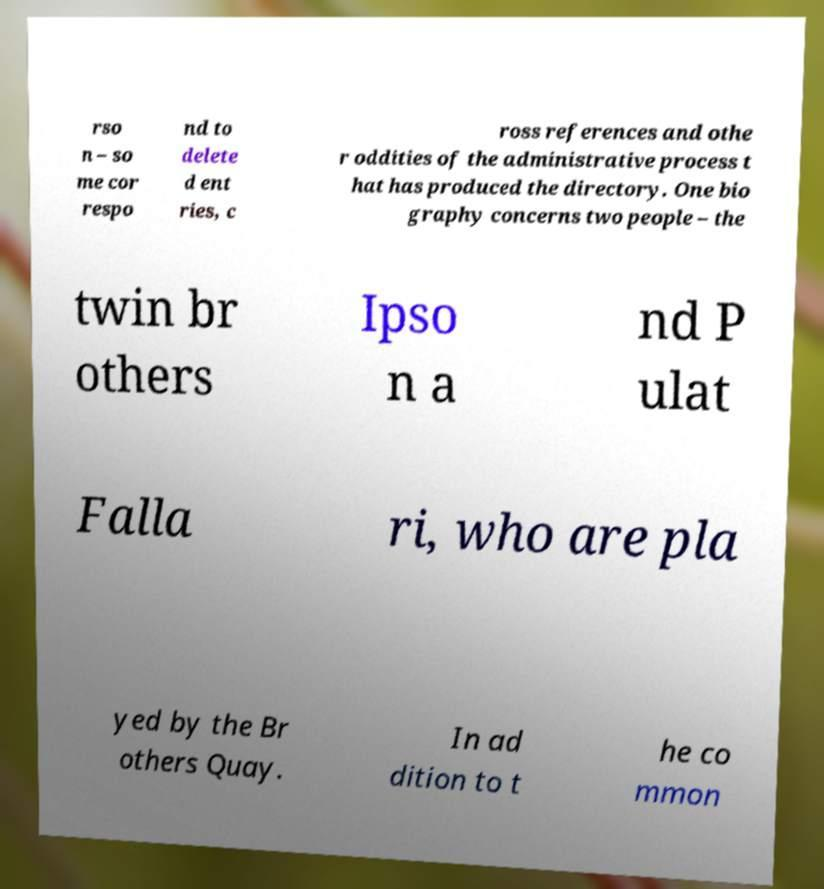Please read and relay the text visible in this image. What does it say? rso n – so me cor respo nd to delete d ent ries, c ross references and othe r oddities of the administrative process t hat has produced the directory. One bio graphy concerns two people – the twin br others Ipso n a nd P ulat Falla ri, who are pla yed by the Br others Quay. In ad dition to t he co mmon 